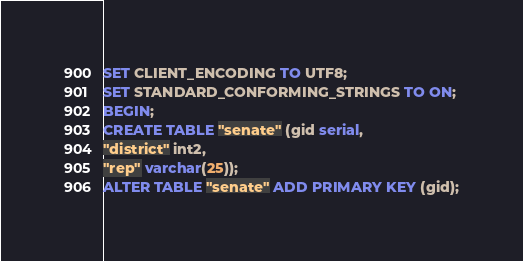Convert code to text. <code><loc_0><loc_0><loc_500><loc_500><_SQL_>SET CLIENT_ENCODING TO UTF8;
SET STANDARD_CONFORMING_STRINGS TO ON;
BEGIN;
CREATE TABLE "senate" (gid serial,
"district" int2,
"rep" varchar(25));
ALTER TABLE "senate" ADD PRIMARY KEY (gid);</code> 